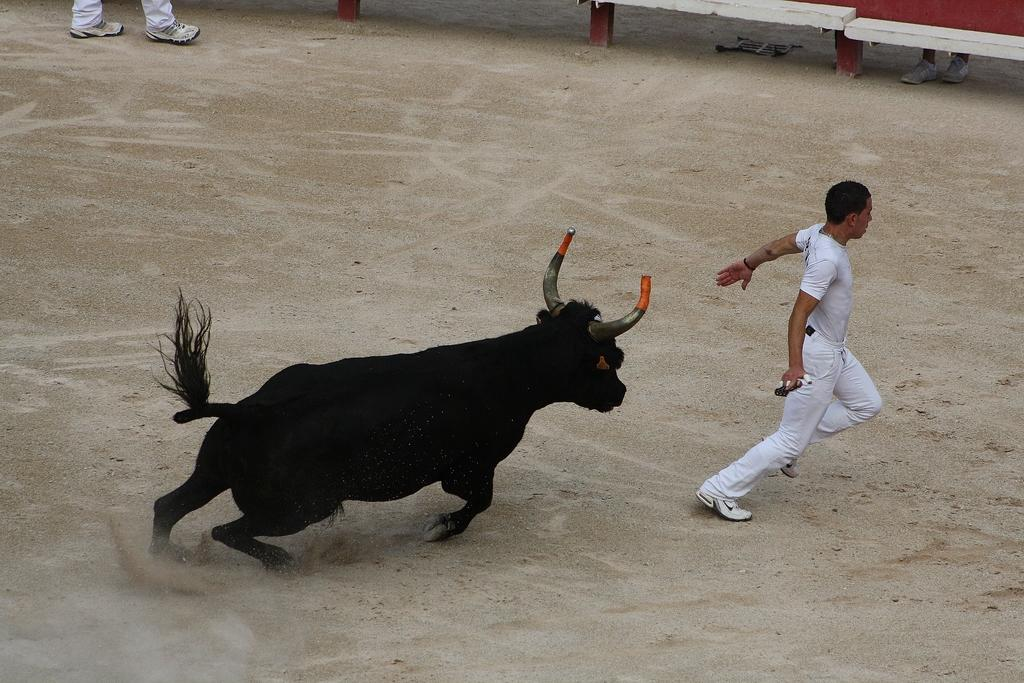What is present in the image? There is a man, a bull, and legs of persons visible in the image. What is the man holding in his hand? The man is holding something in his hand, but the specific object cannot be determined from the facts provided. How close is the bull to the man? The bull is near the man, but the exact distance cannot be determined from the facts provided. What is the ground made of in the image? The ground appears to be sand in the image. How many houses can be seen in the image? There are no houses visible in the image. What type of bee is buzzing around the man's head in the image? There is no bee present in the image. 